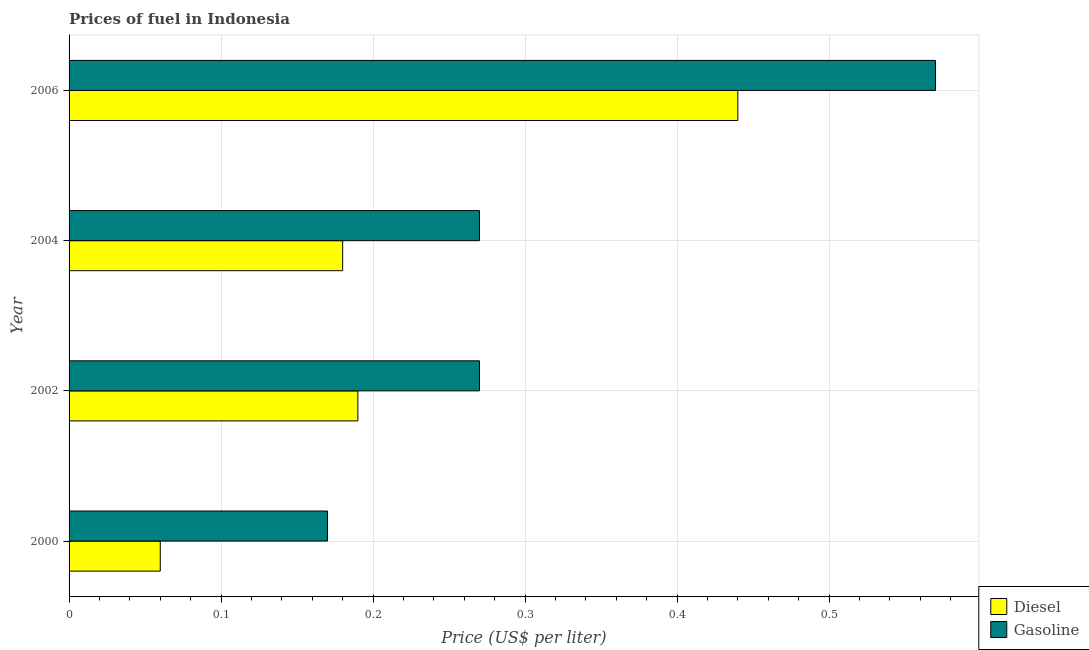How many different coloured bars are there?
Give a very brief answer. 2. How many groups of bars are there?
Offer a very short reply. 4. Are the number of bars per tick equal to the number of legend labels?
Provide a short and direct response. Yes. Are the number of bars on each tick of the Y-axis equal?
Ensure brevity in your answer.  Yes. How many bars are there on the 4th tick from the top?
Offer a terse response. 2. What is the label of the 3rd group of bars from the top?
Keep it short and to the point. 2002. What is the gasoline price in 2006?
Your answer should be very brief. 0.57. Across all years, what is the maximum diesel price?
Provide a short and direct response. 0.44. Across all years, what is the minimum diesel price?
Your answer should be compact. 0.06. In which year was the gasoline price maximum?
Give a very brief answer. 2006. In which year was the diesel price minimum?
Keep it short and to the point. 2000. What is the total diesel price in the graph?
Your answer should be compact. 0.87. What is the difference between the gasoline price in 2000 and that in 2002?
Your response must be concise. -0.1. What is the difference between the diesel price in 2006 and the gasoline price in 2004?
Offer a very short reply. 0.17. What is the average diesel price per year?
Your response must be concise. 0.22. In the year 2004, what is the difference between the gasoline price and diesel price?
Offer a terse response. 0.09. In how many years, is the diesel price greater than 0.52 US$ per litre?
Keep it short and to the point. 0. What is the ratio of the gasoline price in 2000 to that in 2002?
Provide a short and direct response. 0.63. Is the difference between the diesel price in 2002 and 2004 greater than the difference between the gasoline price in 2002 and 2004?
Make the answer very short. Yes. Is the sum of the gasoline price in 2002 and 2006 greater than the maximum diesel price across all years?
Your response must be concise. Yes. What does the 1st bar from the top in 2000 represents?
Your response must be concise. Gasoline. What does the 2nd bar from the bottom in 2004 represents?
Ensure brevity in your answer.  Gasoline. Are the values on the major ticks of X-axis written in scientific E-notation?
Provide a succinct answer. No. Does the graph contain any zero values?
Your response must be concise. No. How many legend labels are there?
Your answer should be very brief. 2. How are the legend labels stacked?
Offer a very short reply. Vertical. What is the title of the graph?
Offer a terse response. Prices of fuel in Indonesia. What is the label or title of the X-axis?
Offer a very short reply. Price (US$ per liter). What is the label or title of the Y-axis?
Provide a succinct answer. Year. What is the Price (US$ per liter) of Gasoline in 2000?
Give a very brief answer. 0.17. What is the Price (US$ per liter) of Diesel in 2002?
Give a very brief answer. 0.19. What is the Price (US$ per liter) of Gasoline in 2002?
Offer a terse response. 0.27. What is the Price (US$ per liter) of Diesel in 2004?
Your answer should be compact. 0.18. What is the Price (US$ per liter) of Gasoline in 2004?
Provide a succinct answer. 0.27. What is the Price (US$ per liter) of Diesel in 2006?
Your answer should be very brief. 0.44. What is the Price (US$ per liter) of Gasoline in 2006?
Give a very brief answer. 0.57. Across all years, what is the maximum Price (US$ per liter) in Diesel?
Provide a short and direct response. 0.44. Across all years, what is the maximum Price (US$ per liter) in Gasoline?
Offer a terse response. 0.57. Across all years, what is the minimum Price (US$ per liter) of Diesel?
Make the answer very short. 0.06. Across all years, what is the minimum Price (US$ per liter) of Gasoline?
Ensure brevity in your answer.  0.17. What is the total Price (US$ per liter) in Diesel in the graph?
Provide a short and direct response. 0.87. What is the total Price (US$ per liter) in Gasoline in the graph?
Offer a terse response. 1.28. What is the difference between the Price (US$ per liter) of Diesel in 2000 and that in 2002?
Your answer should be compact. -0.13. What is the difference between the Price (US$ per liter) of Diesel in 2000 and that in 2004?
Your answer should be very brief. -0.12. What is the difference between the Price (US$ per liter) in Gasoline in 2000 and that in 2004?
Provide a short and direct response. -0.1. What is the difference between the Price (US$ per liter) of Diesel in 2000 and that in 2006?
Offer a very short reply. -0.38. What is the difference between the Price (US$ per liter) in Gasoline in 2000 and that in 2006?
Offer a terse response. -0.4. What is the difference between the Price (US$ per liter) of Diesel in 2004 and that in 2006?
Your answer should be very brief. -0.26. What is the difference between the Price (US$ per liter) in Gasoline in 2004 and that in 2006?
Your answer should be compact. -0.3. What is the difference between the Price (US$ per liter) of Diesel in 2000 and the Price (US$ per liter) of Gasoline in 2002?
Your answer should be very brief. -0.21. What is the difference between the Price (US$ per liter) in Diesel in 2000 and the Price (US$ per liter) in Gasoline in 2004?
Ensure brevity in your answer.  -0.21. What is the difference between the Price (US$ per liter) in Diesel in 2000 and the Price (US$ per liter) in Gasoline in 2006?
Ensure brevity in your answer.  -0.51. What is the difference between the Price (US$ per liter) of Diesel in 2002 and the Price (US$ per liter) of Gasoline in 2004?
Make the answer very short. -0.08. What is the difference between the Price (US$ per liter) in Diesel in 2002 and the Price (US$ per liter) in Gasoline in 2006?
Your answer should be very brief. -0.38. What is the difference between the Price (US$ per liter) in Diesel in 2004 and the Price (US$ per liter) in Gasoline in 2006?
Keep it short and to the point. -0.39. What is the average Price (US$ per liter) of Diesel per year?
Make the answer very short. 0.22. What is the average Price (US$ per liter) in Gasoline per year?
Ensure brevity in your answer.  0.32. In the year 2000, what is the difference between the Price (US$ per liter) of Diesel and Price (US$ per liter) of Gasoline?
Make the answer very short. -0.11. In the year 2002, what is the difference between the Price (US$ per liter) in Diesel and Price (US$ per liter) in Gasoline?
Keep it short and to the point. -0.08. In the year 2004, what is the difference between the Price (US$ per liter) in Diesel and Price (US$ per liter) in Gasoline?
Make the answer very short. -0.09. In the year 2006, what is the difference between the Price (US$ per liter) of Diesel and Price (US$ per liter) of Gasoline?
Offer a terse response. -0.13. What is the ratio of the Price (US$ per liter) of Diesel in 2000 to that in 2002?
Provide a succinct answer. 0.32. What is the ratio of the Price (US$ per liter) of Gasoline in 2000 to that in 2002?
Provide a short and direct response. 0.63. What is the ratio of the Price (US$ per liter) in Diesel in 2000 to that in 2004?
Offer a very short reply. 0.33. What is the ratio of the Price (US$ per liter) in Gasoline in 2000 to that in 2004?
Your answer should be very brief. 0.63. What is the ratio of the Price (US$ per liter) of Diesel in 2000 to that in 2006?
Your answer should be compact. 0.14. What is the ratio of the Price (US$ per liter) in Gasoline in 2000 to that in 2006?
Make the answer very short. 0.3. What is the ratio of the Price (US$ per liter) of Diesel in 2002 to that in 2004?
Ensure brevity in your answer.  1.06. What is the ratio of the Price (US$ per liter) in Diesel in 2002 to that in 2006?
Ensure brevity in your answer.  0.43. What is the ratio of the Price (US$ per liter) of Gasoline in 2002 to that in 2006?
Keep it short and to the point. 0.47. What is the ratio of the Price (US$ per liter) in Diesel in 2004 to that in 2006?
Offer a terse response. 0.41. What is the ratio of the Price (US$ per liter) of Gasoline in 2004 to that in 2006?
Provide a short and direct response. 0.47. What is the difference between the highest and the lowest Price (US$ per liter) in Diesel?
Offer a very short reply. 0.38. 